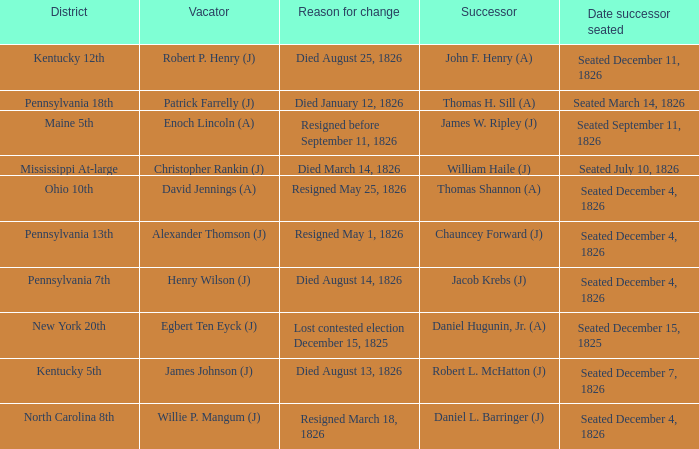Name the vacator for reason for change died january 12, 1826 Patrick Farrelly (J). 